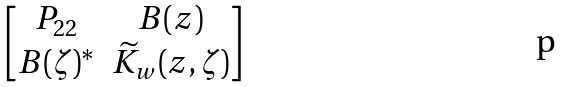Convert formula to latex. <formula><loc_0><loc_0><loc_500><loc_500>\begin{bmatrix} P _ { 2 2 } & B ( z ) \\ B ( \zeta ) ^ { * } & \widetilde { K } _ { w } ( z , \zeta ) \end{bmatrix}</formula> 